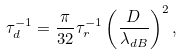Convert formula to latex. <formula><loc_0><loc_0><loc_500><loc_500>\tau _ { d } ^ { - 1 } = \frac { \pi } { 3 2 } \tau _ { r } ^ { - 1 } \left ( \frac { D } { \lambda _ { d B } } \right ) ^ { 2 } ,</formula> 